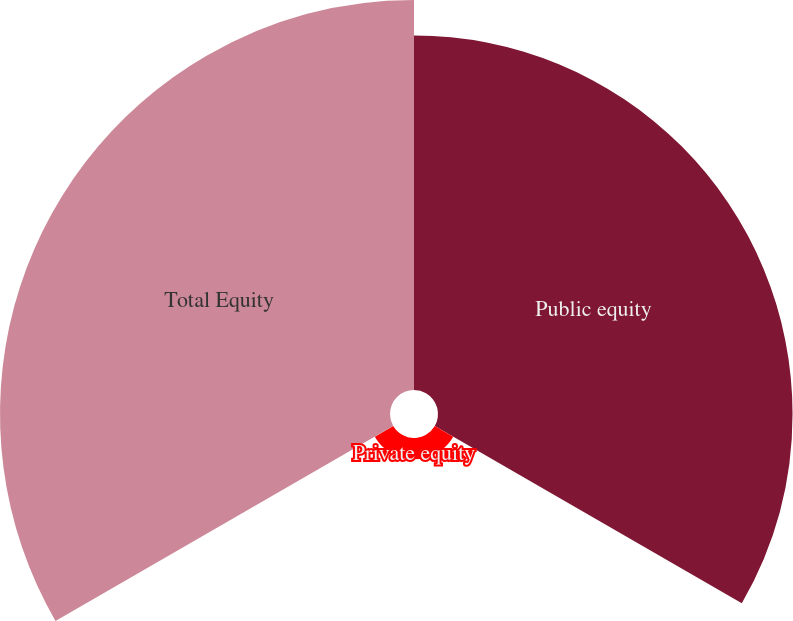Convert chart. <chart><loc_0><loc_0><loc_500><loc_500><pie_chart><fcel>Public equity<fcel>Private equity<fcel>Total Equity<nl><fcel>46.3%<fcel>2.78%<fcel>50.93%<nl></chart> 